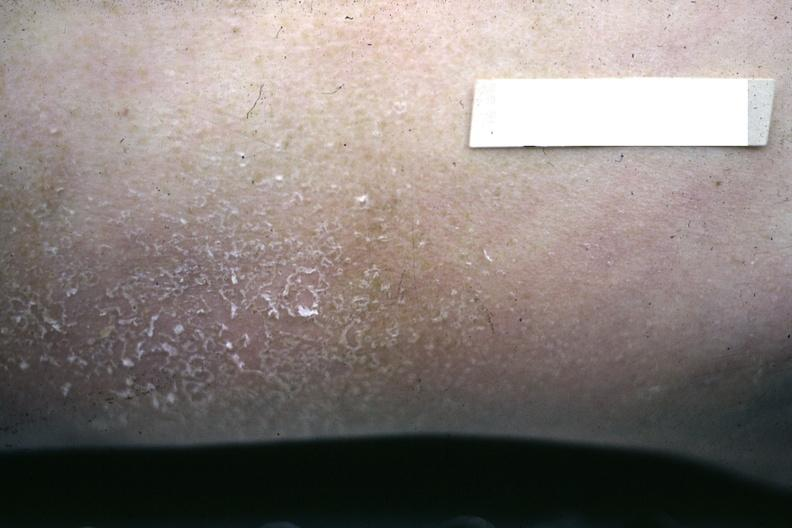s face present?
Answer the question using a single word or phrase. No 